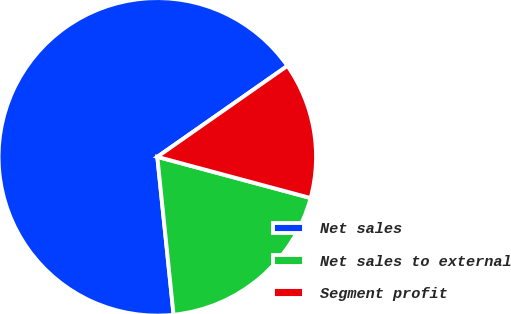Convert chart to OTSL. <chart><loc_0><loc_0><loc_500><loc_500><pie_chart><fcel>Net sales<fcel>Net sales to external<fcel>Segment profit<nl><fcel>66.92%<fcel>19.19%<fcel>13.89%<nl></chart> 